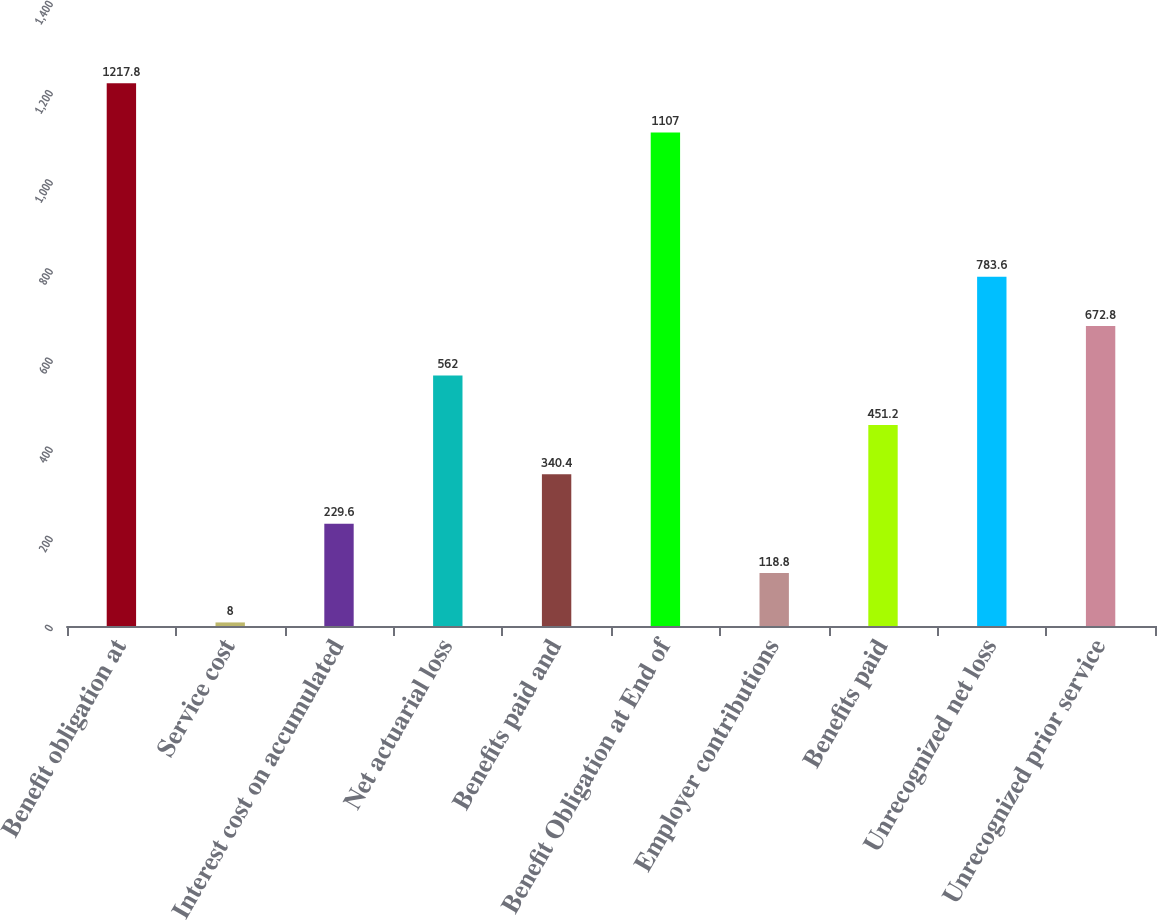<chart> <loc_0><loc_0><loc_500><loc_500><bar_chart><fcel>Benefit obligation at<fcel>Service cost<fcel>Interest cost on accumulated<fcel>Net actuarial loss<fcel>Benefits paid and<fcel>Benefit Obligation at End of<fcel>Employer contributions<fcel>Benefits paid<fcel>Unrecognized net loss<fcel>Unrecognized prior service<nl><fcel>1217.8<fcel>8<fcel>229.6<fcel>562<fcel>340.4<fcel>1107<fcel>118.8<fcel>451.2<fcel>783.6<fcel>672.8<nl></chart> 